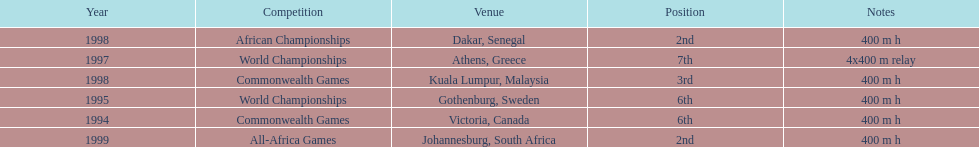What was the venue before dakar, senegal? Kuala Lumpur, Malaysia. 